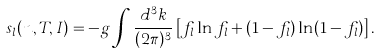<formula> <loc_0><loc_0><loc_500><loc_500>s _ { l } ( n , T , I ) = - g \int \frac { d ^ { 3 } k } { ( 2 \pi ) ^ { 3 } } \left [ f _ { l } \ln f _ { l } + ( 1 - f _ { l } ) \ln ( 1 - f _ { l } ) \right ] .</formula> 